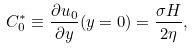Convert formula to latex. <formula><loc_0><loc_0><loc_500><loc_500>C ^ { * } _ { 0 } \equiv \frac { \partial u _ { 0 } } { \partial y } ( y = 0 ) = \frac { \sigma H } { 2 \eta } ,</formula> 